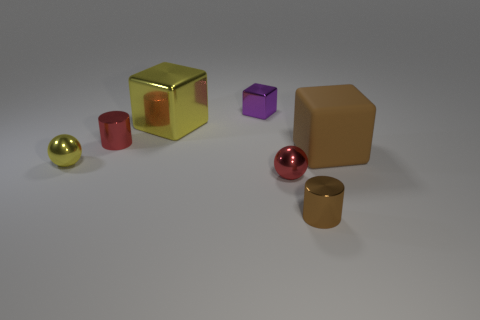Add 2 shiny cubes. How many objects exist? 9 Subtract all blocks. How many objects are left? 4 Add 6 brown rubber cubes. How many brown rubber cubes are left? 7 Add 7 purple blocks. How many purple blocks exist? 8 Subtract 1 yellow spheres. How many objects are left? 6 Subtract all cylinders. Subtract all big blue spheres. How many objects are left? 5 